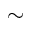Convert formula to latex. <formula><loc_0><loc_0><loc_500><loc_500>\sim</formula> 